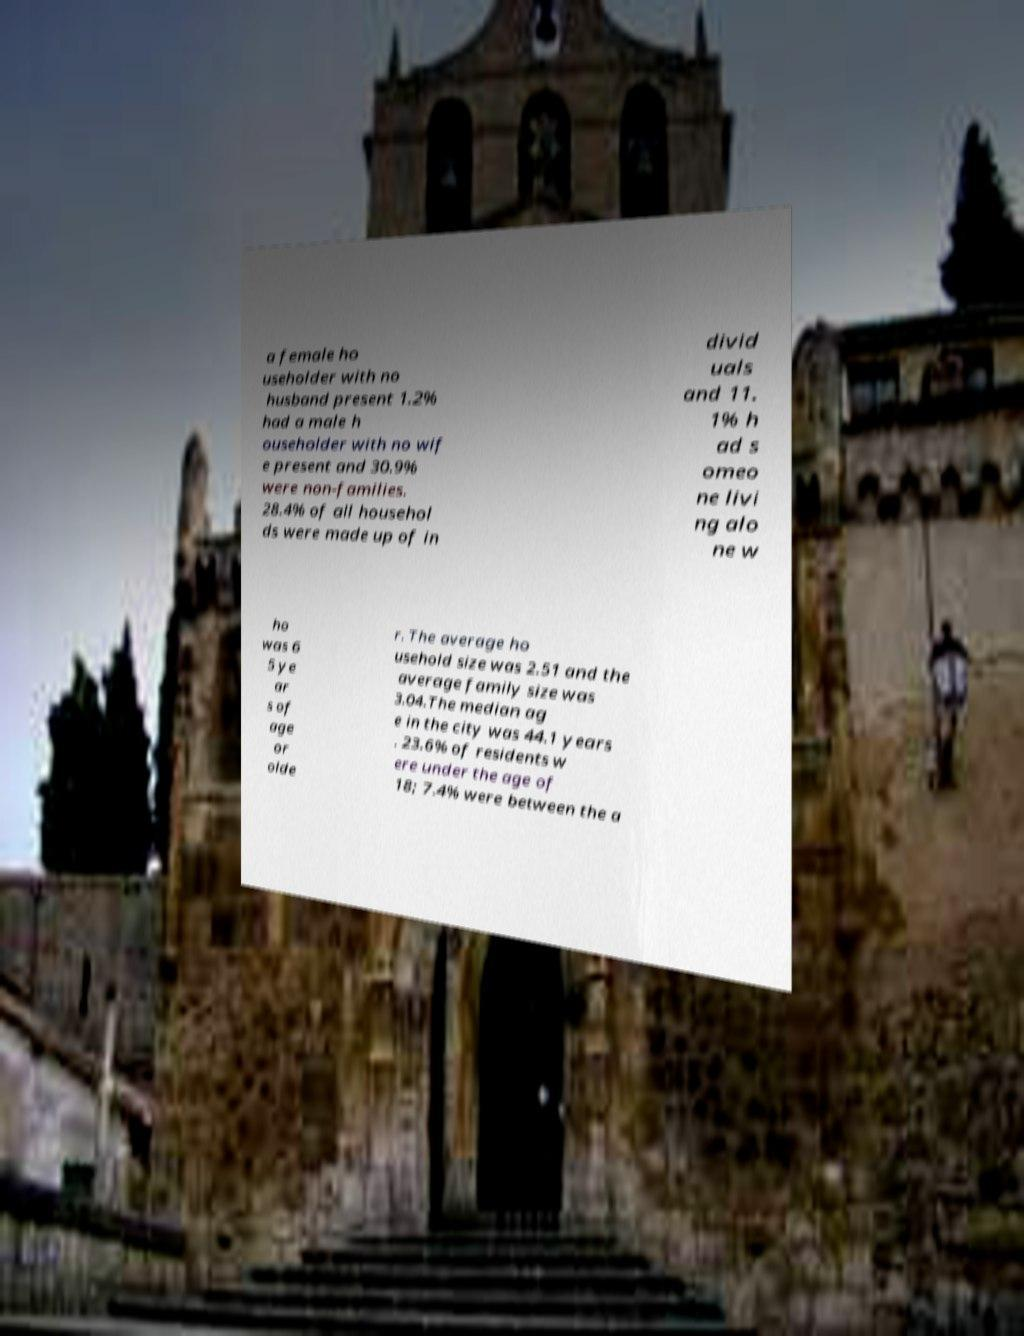Can you accurately transcribe the text from the provided image for me? a female ho useholder with no husband present 1.2% had a male h ouseholder with no wif e present and 30.9% were non-families. 28.4% of all househol ds were made up of in divid uals and 11. 1% h ad s omeo ne livi ng alo ne w ho was 6 5 ye ar s of age or olde r. The average ho usehold size was 2.51 and the average family size was 3.04.The median ag e in the city was 44.1 years . 23.6% of residents w ere under the age of 18; 7.4% were between the a 